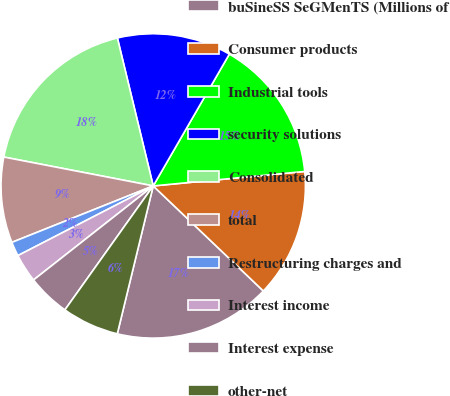Convert chart to OTSL. <chart><loc_0><loc_0><loc_500><loc_500><pie_chart><fcel>buSineSS SeGMenTS (Millions of<fcel>Consumer products<fcel>Industrial tools<fcel>security solutions<fcel>Consolidated<fcel>total<fcel>Restructuring charges and<fcel>Interest income<fcel>Interest expense<fcel>other-net<nl><fcel>16.67%<fcel>13.64%<fcel>15.15%<fcel>12.12%<fcel>18.18%<fcel>9.09%<fcel>1.52%<fcel>3.03%<fcel>4.55%<fcel>6.06%<nl></chart> 